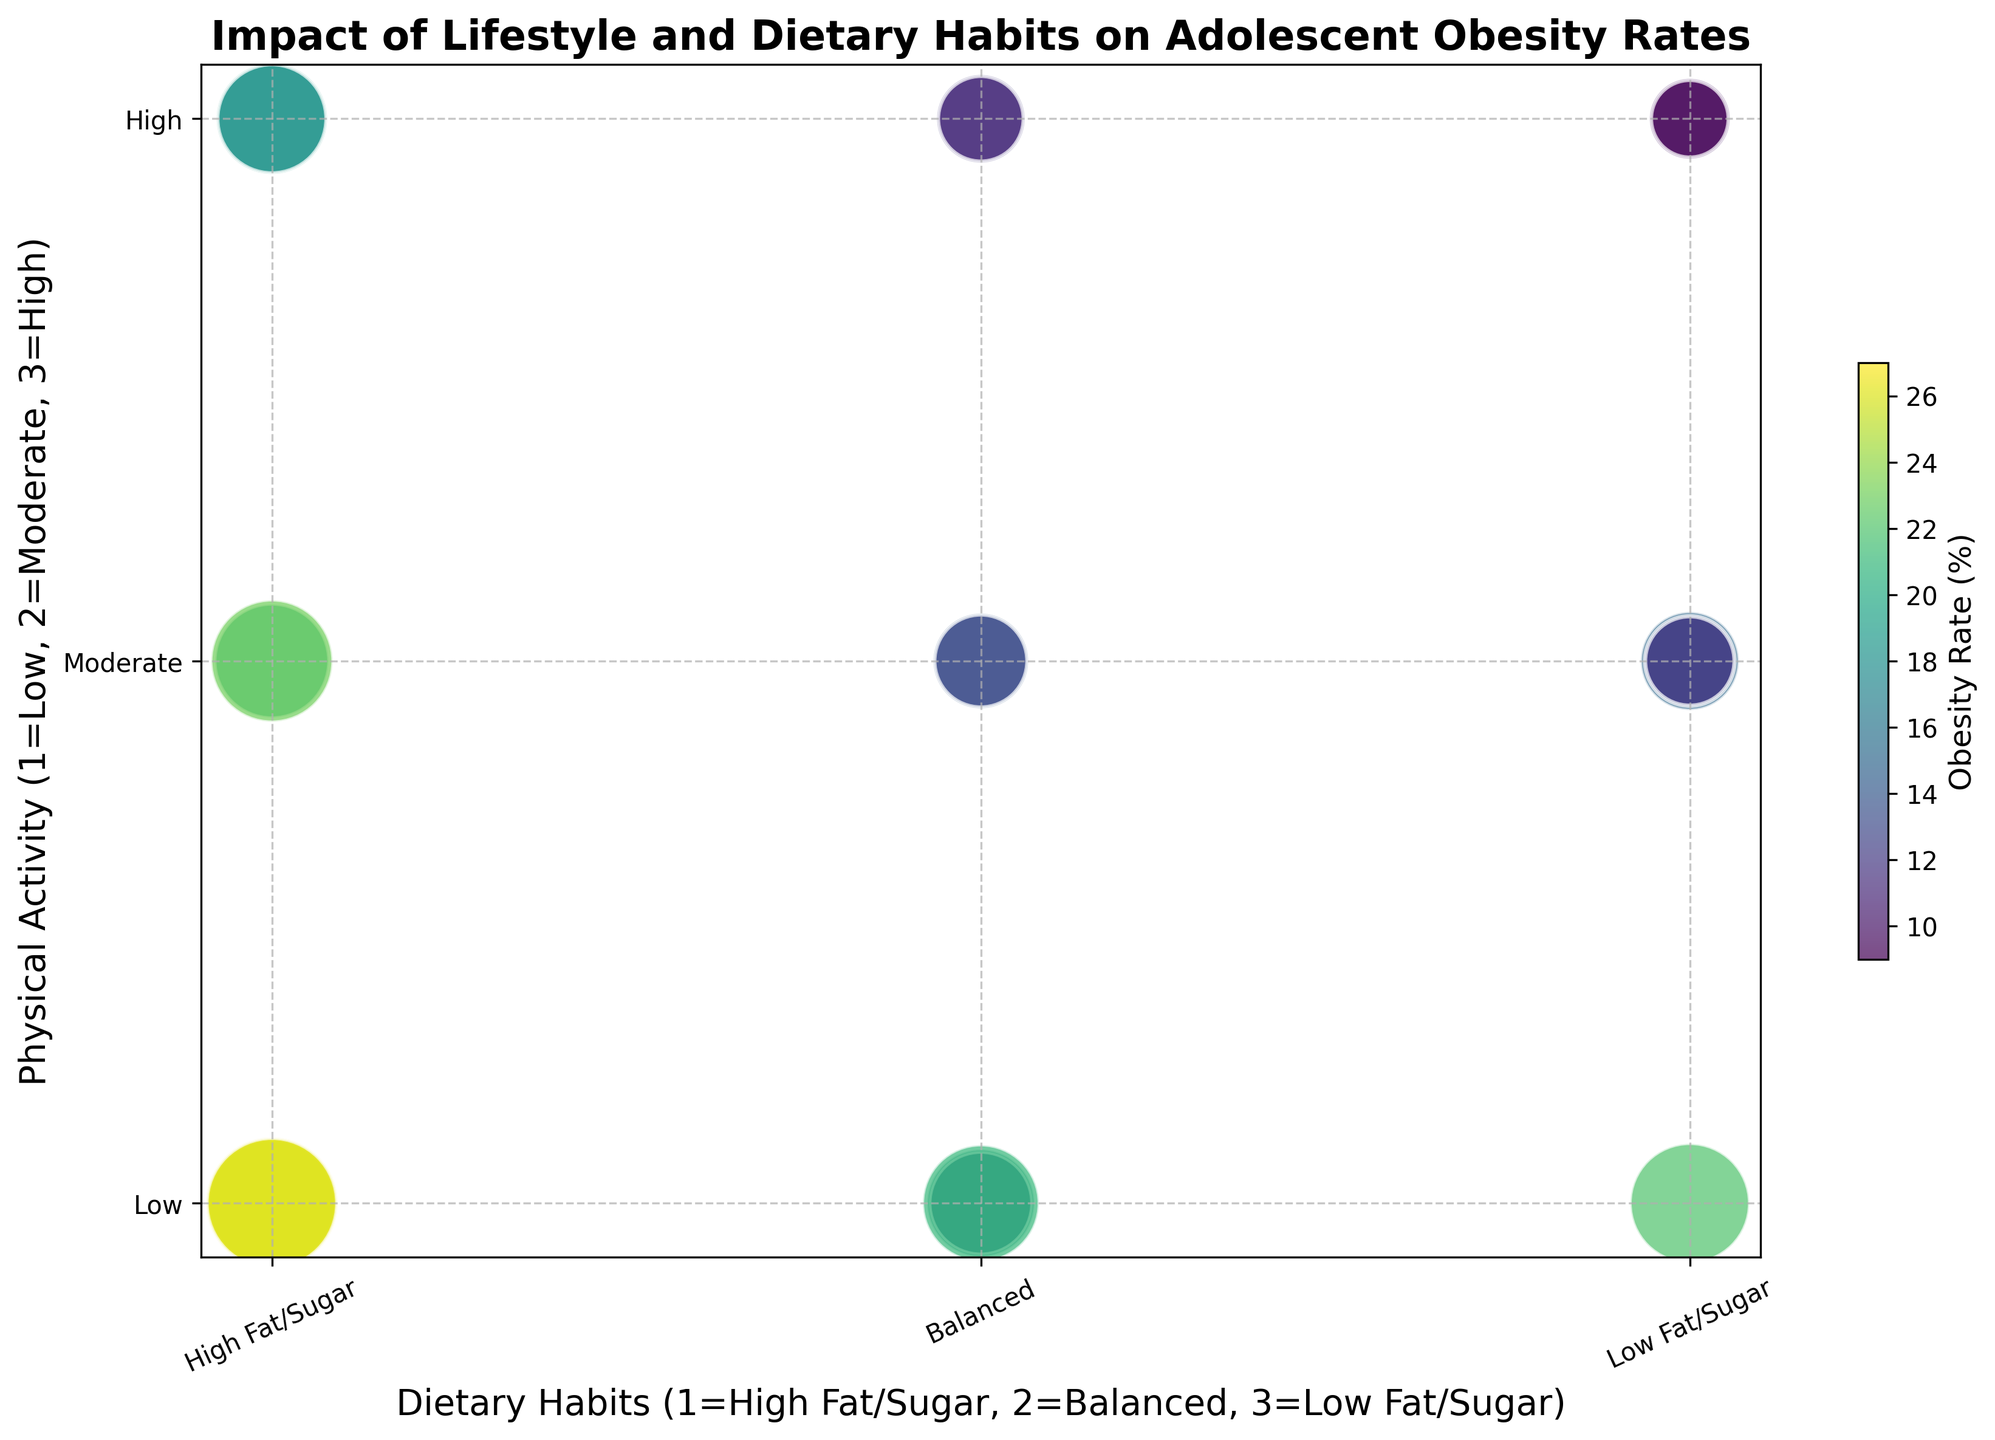What dietary habit category generally shows the highest obesity rates? In the plot, higher obesity rates are represented by larger and darker-colored points. Observing the clusters, the "High Fat/Sugar" category generally shows the highest obesity rates.
Answer: High Fat/Sugar Based on the figure, how does physical activity level correlate with obesity rate for those with high fat/sugar diets? Observing the "High Fat/Sugar" category (1 on the x-axis), higher physical activity levels (higher positions on the y-axis) are associated with generally lower obesity rates, as indicated by smaller and lighter-colored points.
Answer: Higher physical activity correlates with lower obesity rates Which combination of dietary habit and activity level results in the lowest obesity rates? The smallest and lightest-colored points are located at combinations with "Low Fat/Sugar" and "High" physical activity (represented at coordinates 3 on the x-axis and 3 on the y-axis).
Answer: Low Fat/Sugar and High physical activity Compare the obesity rates between balanced dietary habits with low physical activity levels and balanced dietary habits with high physical activity levels. For "Balanced" dietary habits (2 on the x-axis), comparing low (1 on the y-axis) and high (3 on the y-axis) physical activity shows that the high physical activity level generally has smaller and lighter-colored points, indicating lower obesity rates.
Answer: Higher physical activity correlates with lower obesity rates Which group shows a greater range of obesity rates: high fat/sugar diets or balanced diets? By examining the range in the size and color of the points within each category, "High Fat/Sugar" (1 on the x-axis) shows a greater variability, from very dark and large points to smaller and lighter ones, compared to the "Balanced" category (2 on the x-axis).
Answer: High Fat/Sugar How does screen time factor into obesity rates related to balanced dietary habits? Noticing the "Balanced" dietary habits (2 on the x-axis), higher screen time, evidenced by larger point sizes, often corresponds with higher obesity rates. For each obesity rate, screen time data (size of points) should be checked, larger points generally mean more screen time.
Answer: Higher screen time correlates with higher obesity rates What's the average obesity rate for low-fat/sugar diets with moderate physical activity levels? For "Low Fat/Sugar" dietary habits (3 on the x-axis), and "Moderate" physical activity levels (2 on the y-axis), the obesity rates from the figure are indicated by the size and color of the points around these coordinates. Summing obesity rates at (7 + 5 + 4)/3 gives the average.
Answer: 12% Which physical activity level, when paired with high fat/sugar diets, results in the highest obesity rate? For "High Fat/Sugar" dietary habits (1 on the x-axis), the lowest physical activity level (1 on the y-axis) shows the largest and darkest-colored points, indicating the highest obesity rate.
Answer: Low physical activity (Level 1) Between balanced dietary habits with moderate activity and low-fat/sugar dietary habits with moderate activity, which group exhibits lower obesity rates? For "Balanced" (2 on the x-axis) and "Moderate" activity (2 on y-axis) compared to "Low Fat/Sugar" (3 on the x-axis) and "Moderate" activity (2 on y-axis), the latter generally shows smaller and lighter-colored points, indicating lower obesity rates.
Answer: Low Fat/Sugar with Moderate activity 